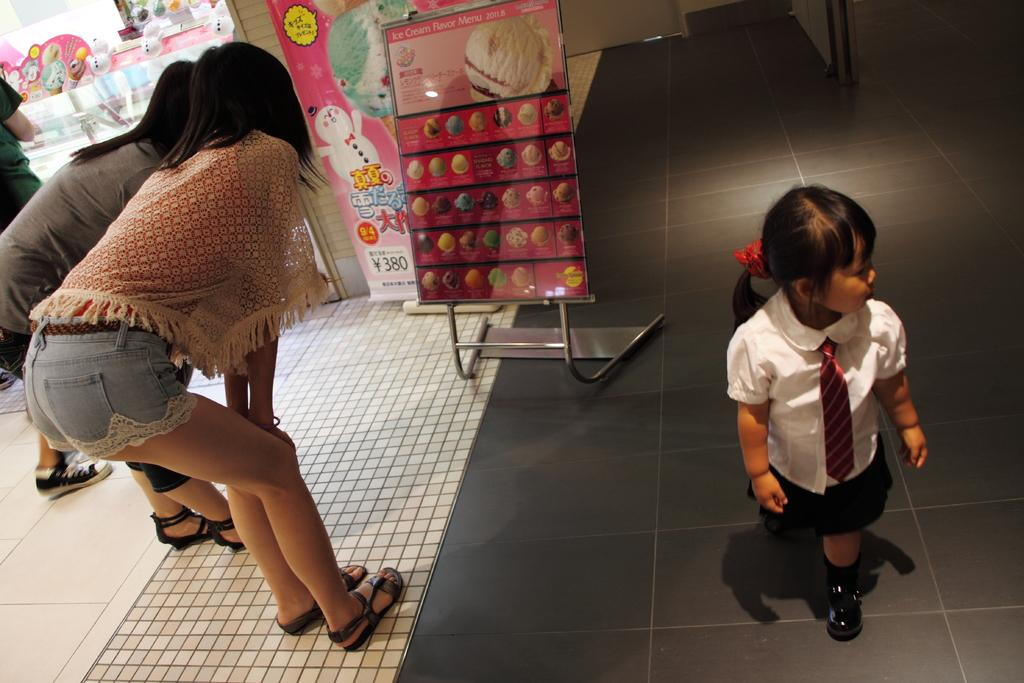What is the main subject of the image? The main subject of the image is a group of girls. What is the small girl doing in the image? There is a small girl walking on the floor. What are the other two girls doing in the image? The other two girls are standing and looking at a poster. Where is the third girl located in the image? The third girl is standing near a shop. What flavor of ice cream is the small girl holding in the image? There is no ice cream present in the image; the small girl is walking on the floor. What type of knee injury can be seen on the poster the girls are looking at? There is no mention of a poster about knee injuries in the image; the girls are looking at a poster, but its content is not specified. 